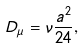Convert formula to latex. <formula><loc_0><loc_0><loc_500><loc_500>D _ { \mu } = \nu \frac { a ^ { 2 } } { 2 4 } ,</formula> 